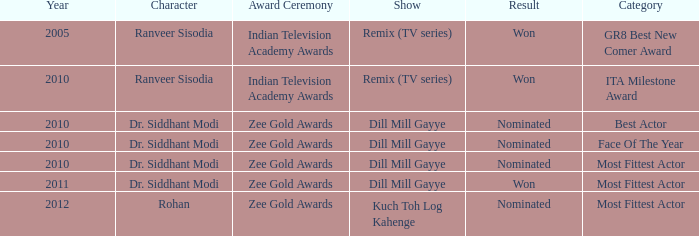Which character was nominated in the 2010 Indian Television Academy Awards? Ranveer Sisodia. 